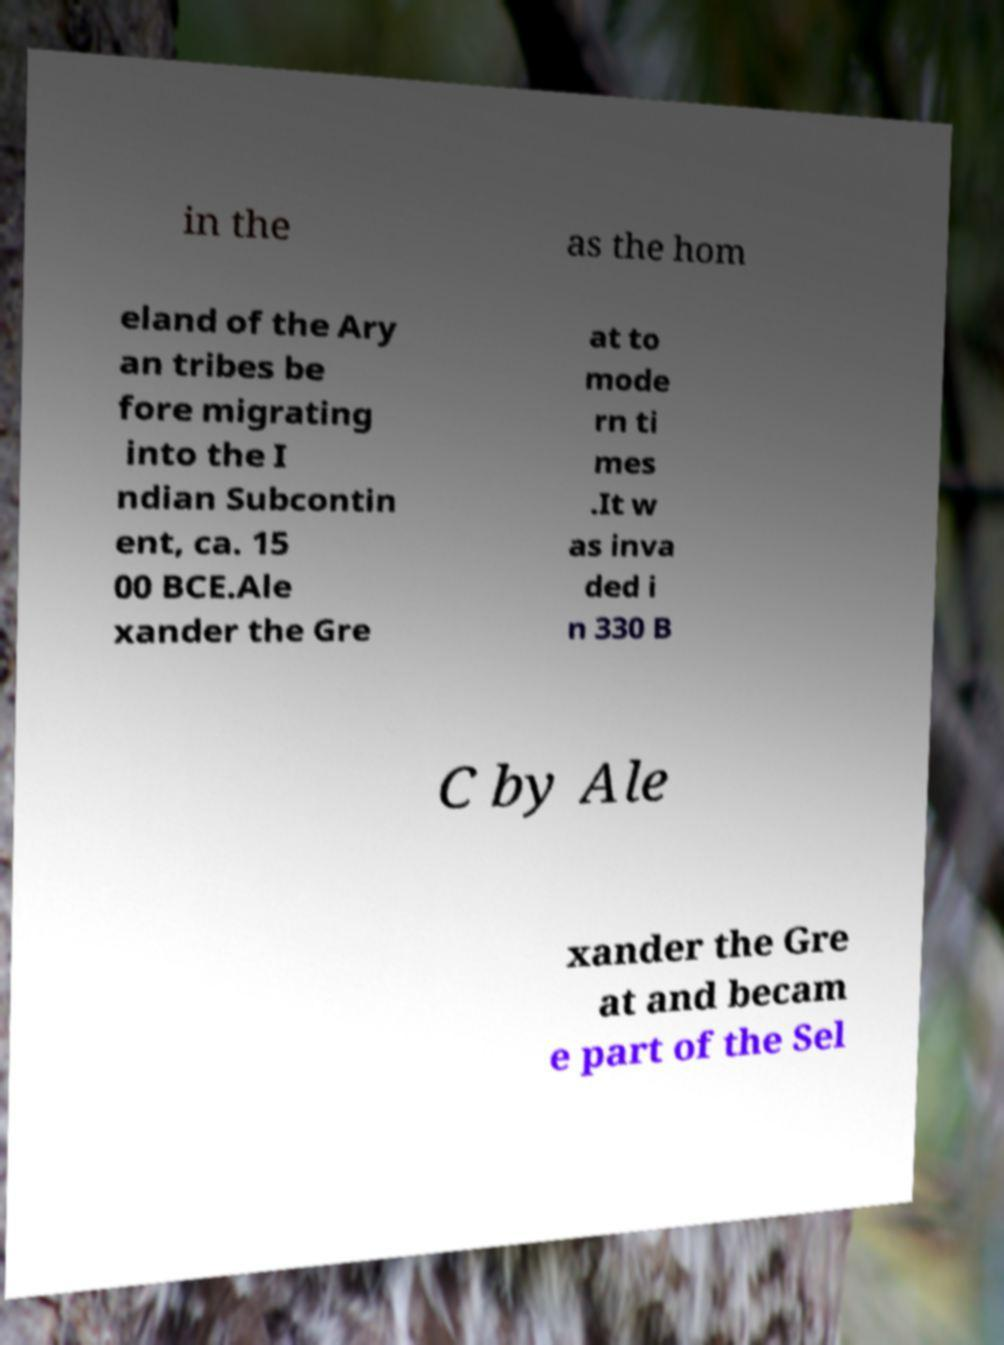I need the written content from this picture converted into text. Can you do that? in the as the hom eland of the Ary an tribes be fore migrating into the I ndian Subcontin ent, ca. 15 00 BCE.Ale xander the Gre at to mode rn ti mes .It w as inva ded i n 330 B C by Ale xander the Gre at and becam e part of the Sel 